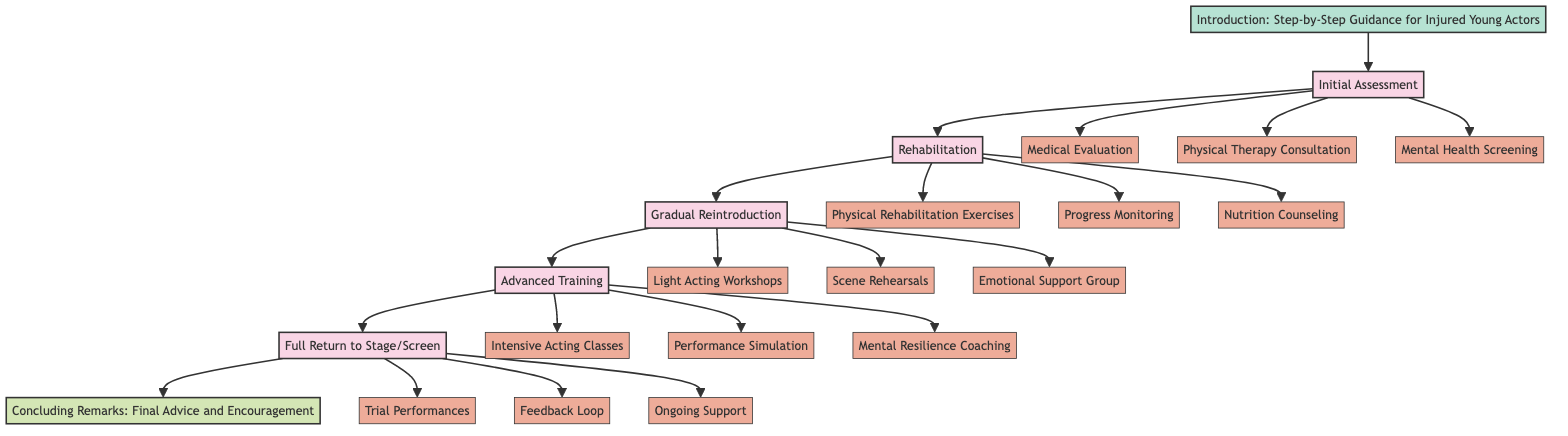What is the first stage in the clinical pathway? The first stage in the clinical pathway is labeled and indicated as "Initial Assessment." This can be found at the top level of the stages in the diagram.
Answer: Initial Assessment How many total stages are there in the clinical pathway? The total number of stages in the clinical pathway can be counted by identifying each distinct stage node from the diagram. There are five stages visible in the flow.
Answer: Five What element follows "Mental Health Screening" in the Initial Assessment stage? In the Initial Assessment stage, the "Mental Health Screening" element is directly followed by the "Rehabilitation" stage in the flow. Thus, it transitions into the next stage without any immediate elements after it.
Answer: Rehabilitation Which stage includes "Nutrition Counseling"? "Nutrition Counseling" is an element listed under the "Rehabilitation" stage in the clinical pathway. This is identifiable as you navigate through the diagram to the second stage.
Answer: Rehabilitation What element is part of the "Full Return to Stage/Screen" stage? The "Full Return to Stage/Screen" stage includes several elements, among which "Trial Performances" is one of the components. This can be found as the first element under that stage.
Answer: Trial Performances Which elements are involved in the "Gradual Reintroduction" stage? The elements that make up the "Gradual Reintroduction" stage are "Light Acting Workshops," "Scene Rehearsals," and "Emotional Support Group." These three elements can be listed by observing the contents of that specific stage in the diagram.
Answer: Light Acting Workshops, Scene Rehearsals, Emotional Support Group What is the purpose of the "Feedback Loop" element? The "Feedback Loop" element serves the purpose of providing regular feedback from various stakeholders to ensure ongoing recovery and adjustment upon full return. This indicates a supportive measure within the final stage.
Answer: To ensure sustained recovery How are the stages connected in the diagram? The stages are connected sequentially, with each stage leading into the next. For example, from "Initial Assessment" to "Rehabilitation," each connection facilitates a structured progression from assessing the injury to finally returning to the stage or screen. This follows a linear flow of recovery steps.
Answer: Sequentially connected What does the concluding remarks section provide? The concluding remarks section, titled "Final Advice and Encouragement," aims to provide motivation and emphasize the importance of health and well-being alongside professional success for the young actors. This indicates a supportive and positive closure to the pathway process.
Answer: Motivation and encouragement 